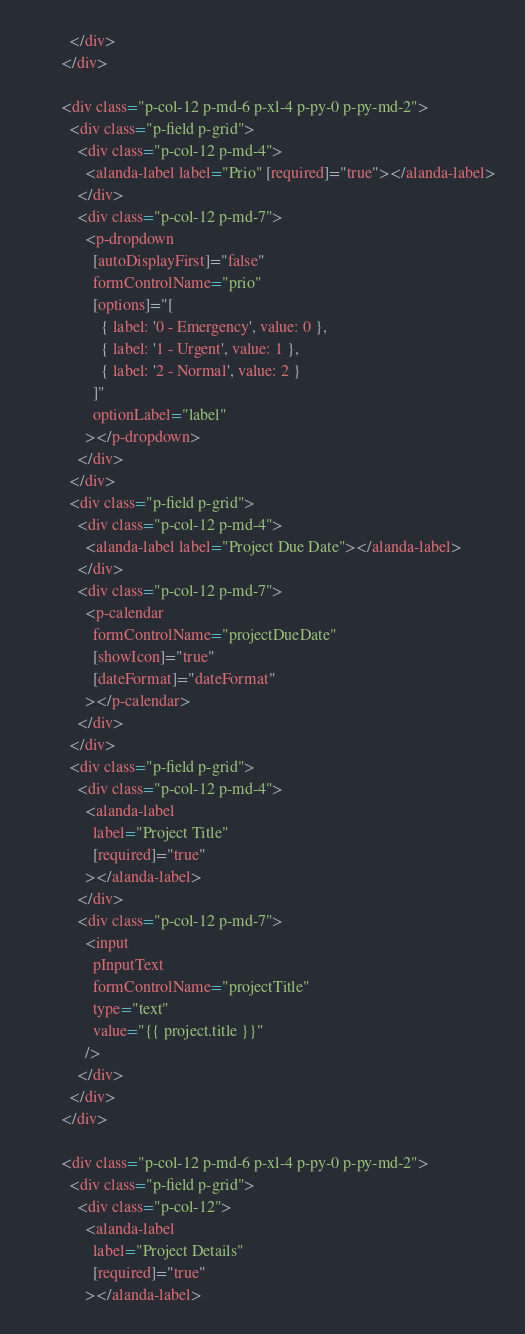<code> <loc_0><loc_0><loc_500><loc_500><_HTML_>          </div>
        </div>

        <div class="p-col-12 p-md-6 p-xl-4 p-py-0 p-py-md-2">
          <div class="p-field p-grid">
            <div class="p-col-12 p-md-4">
              <alanda-label label="Prio" [required]="true"></alanda-label>
            </div>
            <div class="p-col-12 p-md-7">
              <p-dropdown
                [autoDisplayFirst]="false"
                formControlName="prio"
                [options]="[
                  { label: '0 - Emergency', value: 0 },
                  { label: '1 - Urgent', value: 1 },
                  { label: '2 - Normal', value: 2 }
                ]"
                optionLabel="label"
              ></p-dropdown>
            </div>
          </div>
          <div class="p-field p-grid">
            <div class="p-col-12 p-md-4">
              <alanda-label label="Project Due Date"></alanda-label>
            </div>
            <div class="p-col-12 p-md-7">
              <p-calendar
                formControlName="projectDueDate"
                [showIcon]="true"
                [dateFormat]="dateFormat"
              ></p-calendar>
            </div>
          </div>
          <div class="p-field p-grid">
            <div class="p-col-12 p-md-4">
              <alanda-label
                label="Project Title"
                [required]="true"
              ></alanda-label>
            </div>
            <div class="p-col-12 p-md-7">
              <input
                pInputText
                formControlName="projectTitle"
                type="text"
                value="{{ project.title }}"
              />
            </div>
          </div>
        </div>

        <div class="p-col-12 p-md-6 p-xl-4 p-py-0 p-py-md-2">
          <div class="p-field p-grid">
            <div class="p-col-12">
              <alanda-label
                label="Project Details"
                [required]="true"
              ></alanda-label></code> 